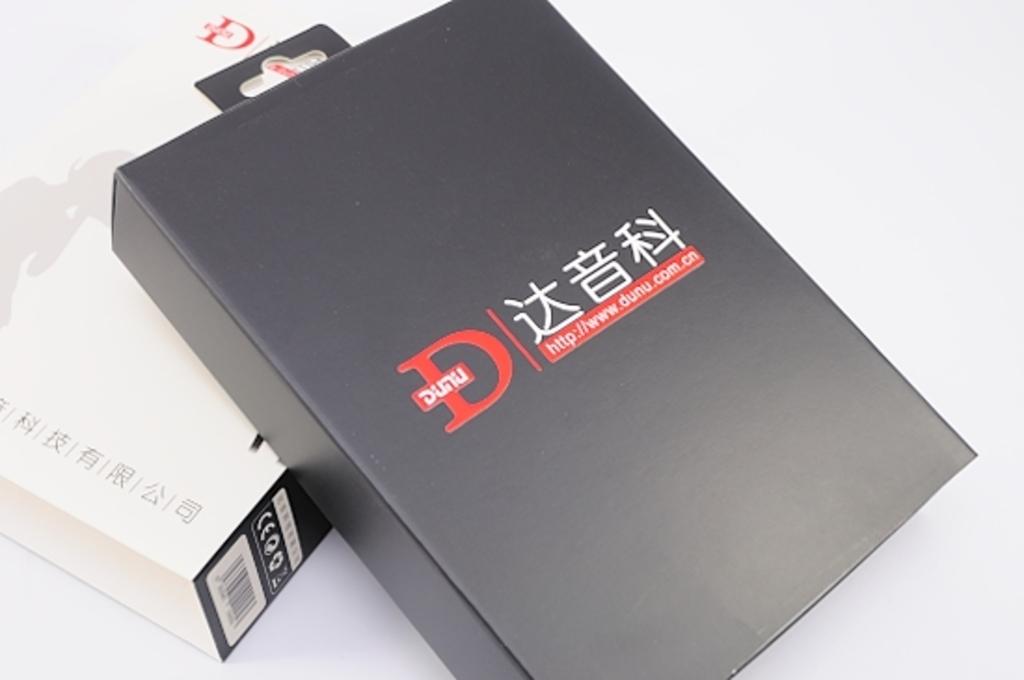What is the big red letter?
Offer a terse response. D. 